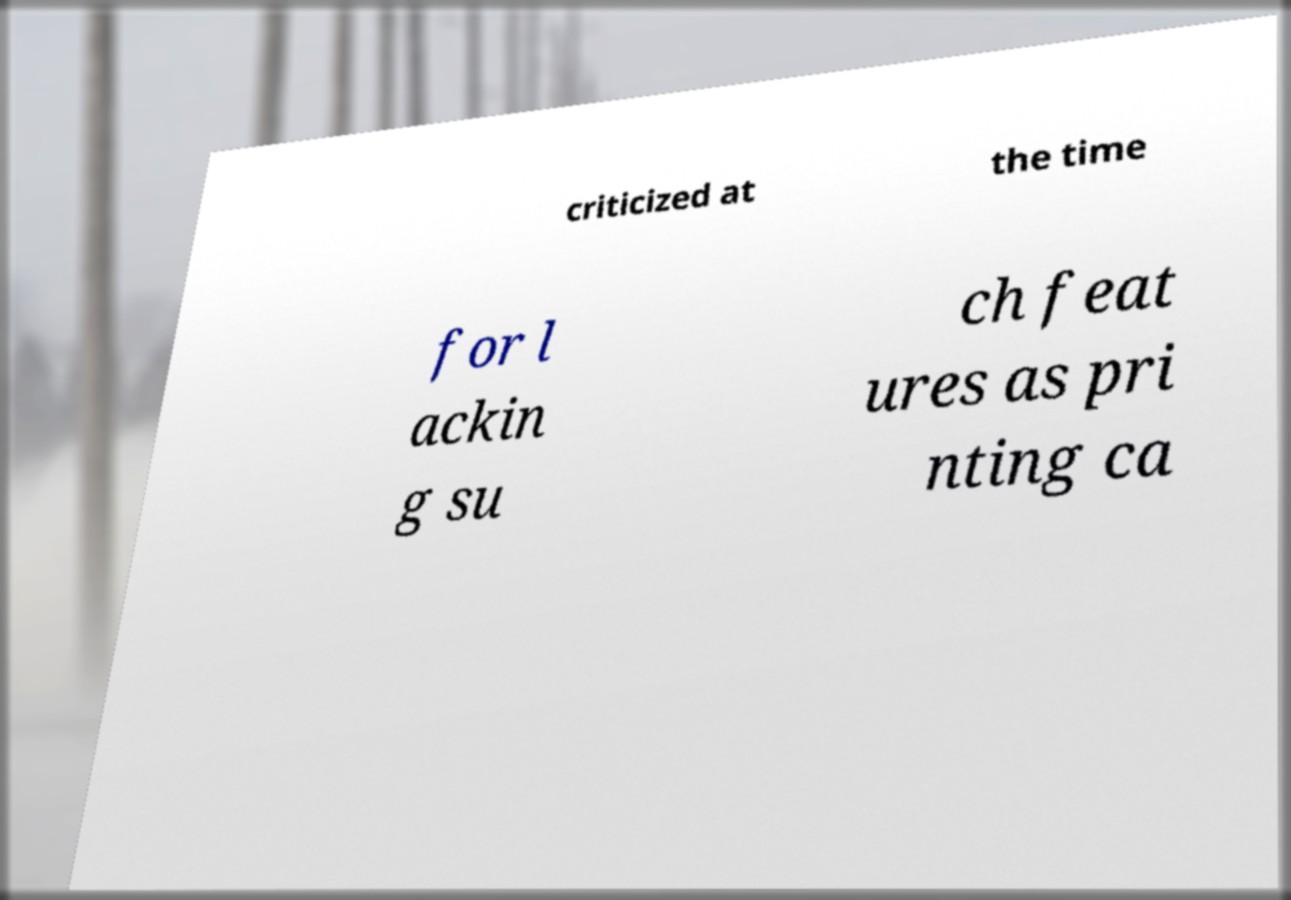What messages or text are displayed in this image? I need them in a readable, typed format. criticized at the time for l ackin g su ch feat ures as pri nting ca 